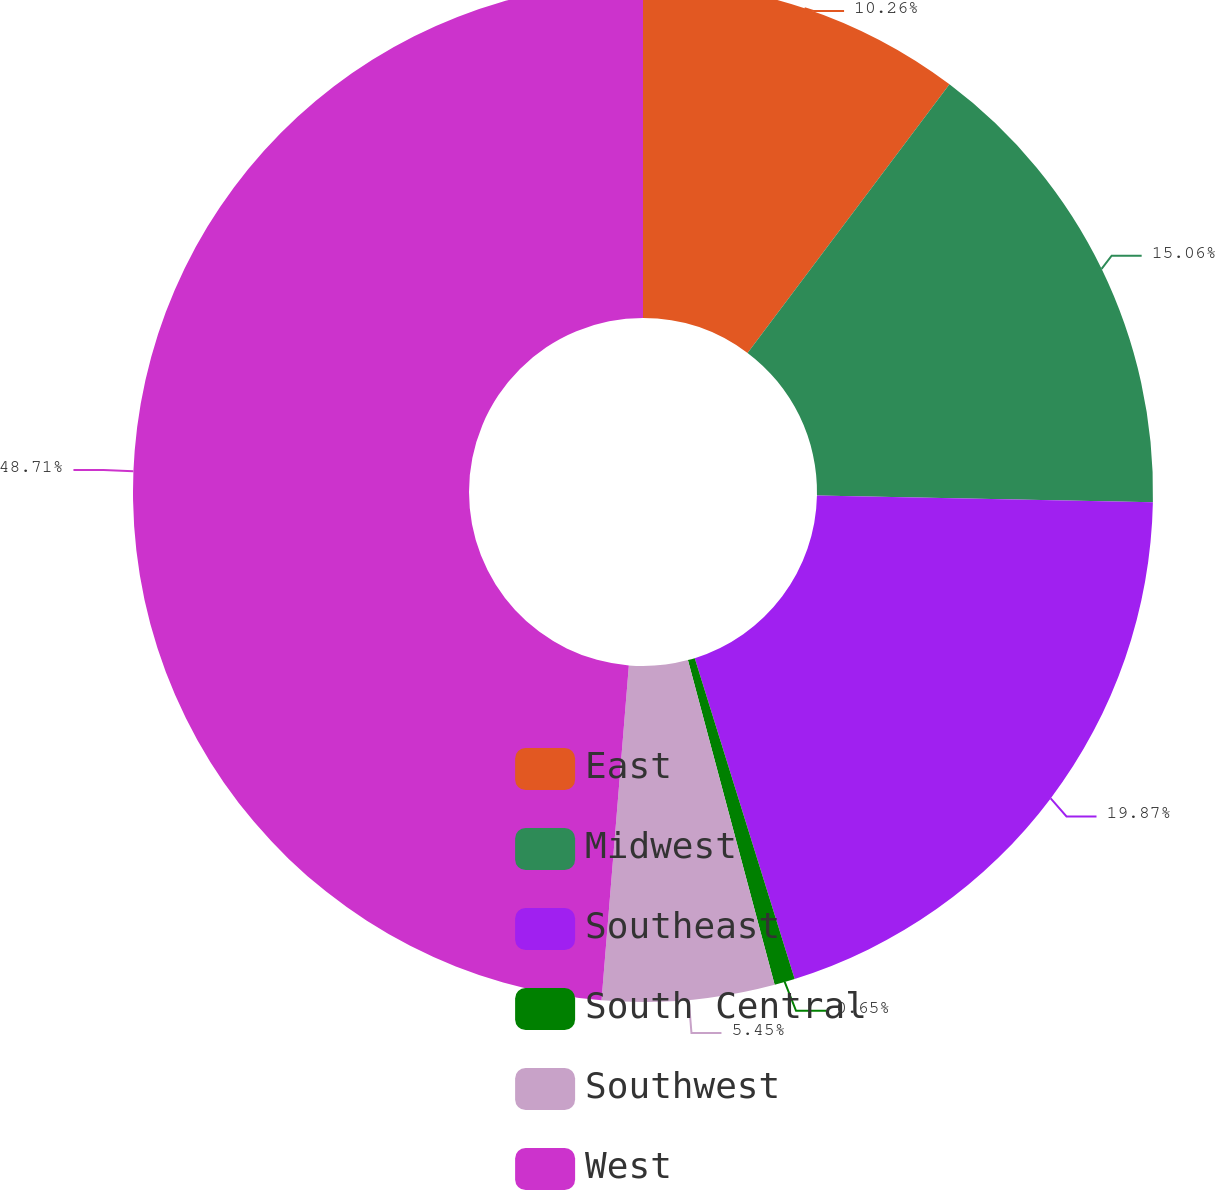Convert chart. <chart><loc_0><loc_0><loc_500><loc_500><pie_chart><fcel>East<fcel>Midwest<fcel>Southeast<fcel>South Central<fcel>Southwest<fcel>West<nl><fcel>10.26%<fcel>15.06%<fcel>19.87%<fcel>0.65%<fcel>5.45%<fcel>48.7%<nl></chart> 